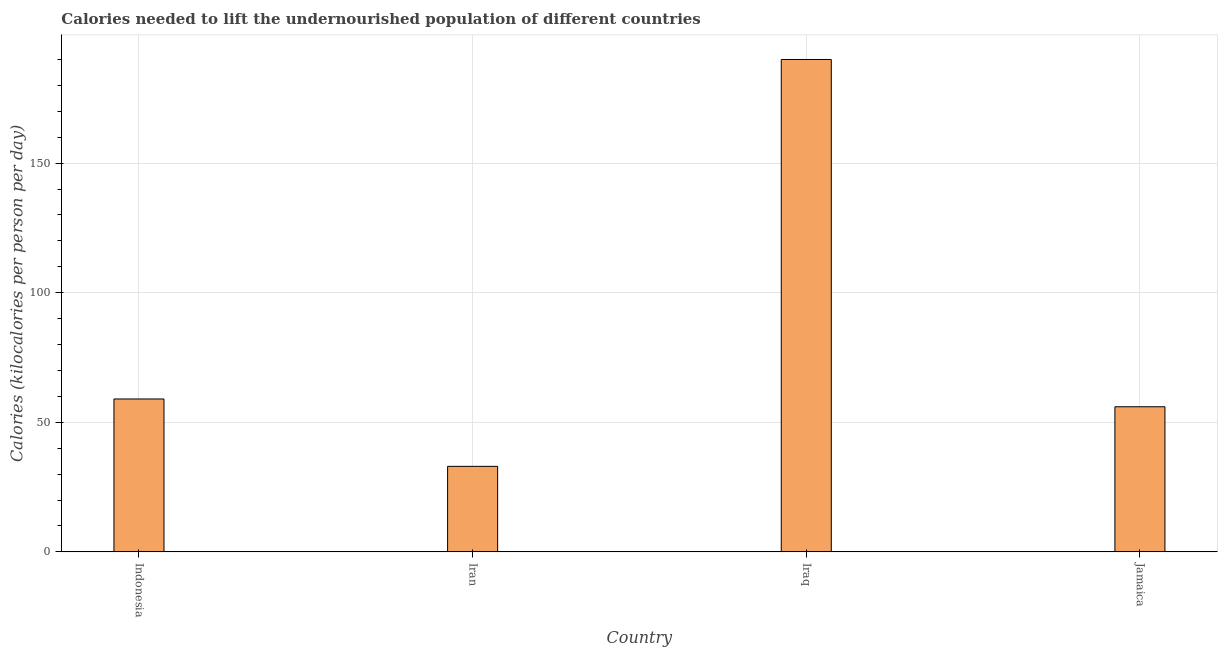Does the graph contain grids?
Make the answer very short. Yes. What is the title of the graph?
Your answer should be compact. Calories needed to lift the undernourished population of different countries. What is the label or title of the Y-axis?
Give a very brief answer. Calories (kilocalories per person per day). Across all countries, what is the maximum depth of food deficit?
Offer a terse response. 190. Across all countries, what is the minimum depth of food deficit?
Give a very brief answer. 33. In which country was the depth of food deficit maximum?
Your answer should be compact. Iraq. In which country was the depth of food deficit minimum?
Your answer should be compact. Iran. What is the sum of the depth of food deficit?
Provide a succinct answer. 338. What is the average depth of food deficit per country?
Give a very brief answer. 84.5. What is the median depth of food deficit?
Give a very brief answer. 57.5. What is the ratio of the depth of food deficit in Iraq to that in Jamaica?
Your response must be concise. 3.39. Is the depth of food deficit in Indonesia less than that in Iraq?
Keep it short and to the point. Yes. Is the difference between the depth of food deficit in Iran and Jamaica greater than the difference between any two countries?
Ensure brevity in your answer.  No. What is the difference between the highest and the second highest depth of food deficit?
Your answer should be compact. 131. Is the sum of the depth of food deficit in Iran and Iraq greater than the maximum depth of food deficit across all countries?
Your answer should be compact. Yes. What is the difference between the highest and the lowest depth of food deficit?
Provide a short and direct response. 157. How many bars are there?
Offer a very short reply. 4. What is the difference between two consecutive major ticks on the Y-axis?
Your answer should be very brief. 50. What is the Calories (kilocalories per person per day) in Iran?
Keep it short and to the point. 33. What is the Calories (kilocalories per person per day) in Iraq?
Provide a succinct answer. 190. What is the difference between the Calories (kilocalories per person per day) in Indonesia and Iraq?
Your response must be concise. -131. What is the difference between the Calories (kilocalories per person per day) in Iran and Iraq?
Make the answer very short. -157. What is the difference between the Calories (kilocalories per person per day) in Iraq and Jamaica?
Your answer should be very brief. 134. What is the ratio of the Calories (kilocalories per person per day) in Indonesia to that in Iran?
Give a very brief answer. 1.79. What is the ratio of the Calories (kilocalories per person per day) in Indonesia to that in Iraq?
Your response must be concise. 0.31. What is the ratio of the Calories (kilocalories per person per day) in Indonesia to that in Jamaica?
Provide a succinct answer. 1.05. What is the ratio of the Calories (kilocalories per person per day) in Iran to that in Iraq?
Provide a short and direct response. 0.17. What is the ratio of the Calories (kilocalories per person per day) in Iran to that in Jamaica?
Keep it short and to the point. 0.59. What is the ratio of the Calories (kilocalories per person per day) in Iraq to that in Jamaica?
Give a very brief answer. 3.39. 